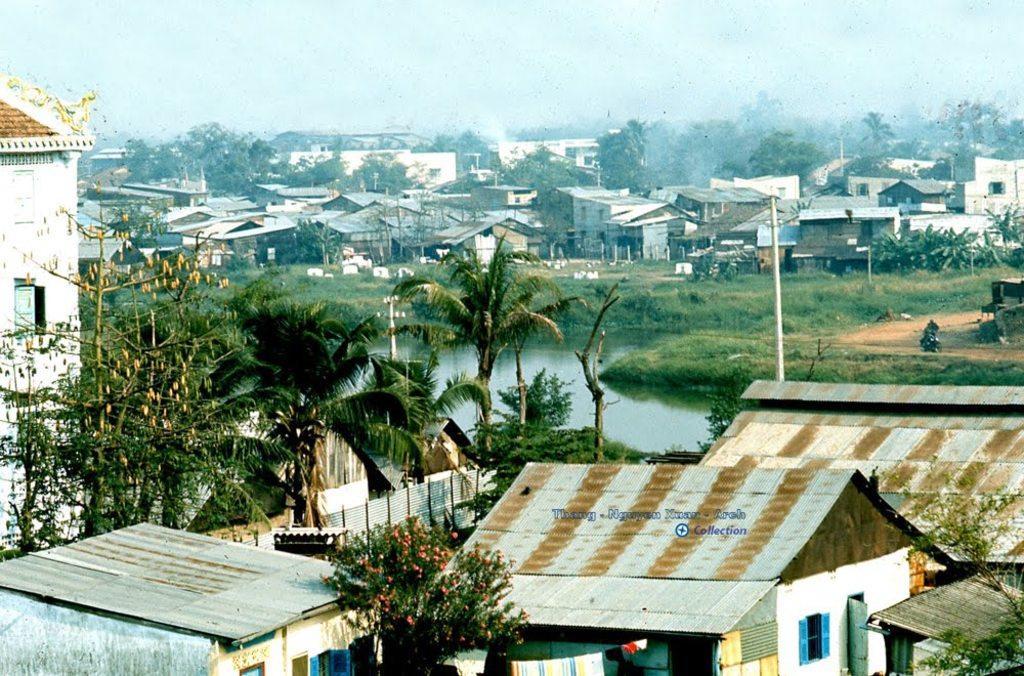Please provide a concise description of this image. In this picture we can see few houses, trees and poles, in the middle of the image we can see water. 